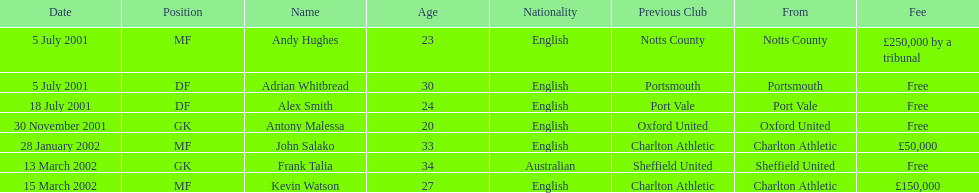What are all of the names? Andy Hughes, Adrian Whitbread, Alex Smith, Antony Malessa, John Salako, Frank Talia, Kevin Watson. What was the fee for each person? £250,000 by a tribunal, Free, Free, Free, £50,000, Free, £150,000. And who had the highest fee? Andy Hughes. 